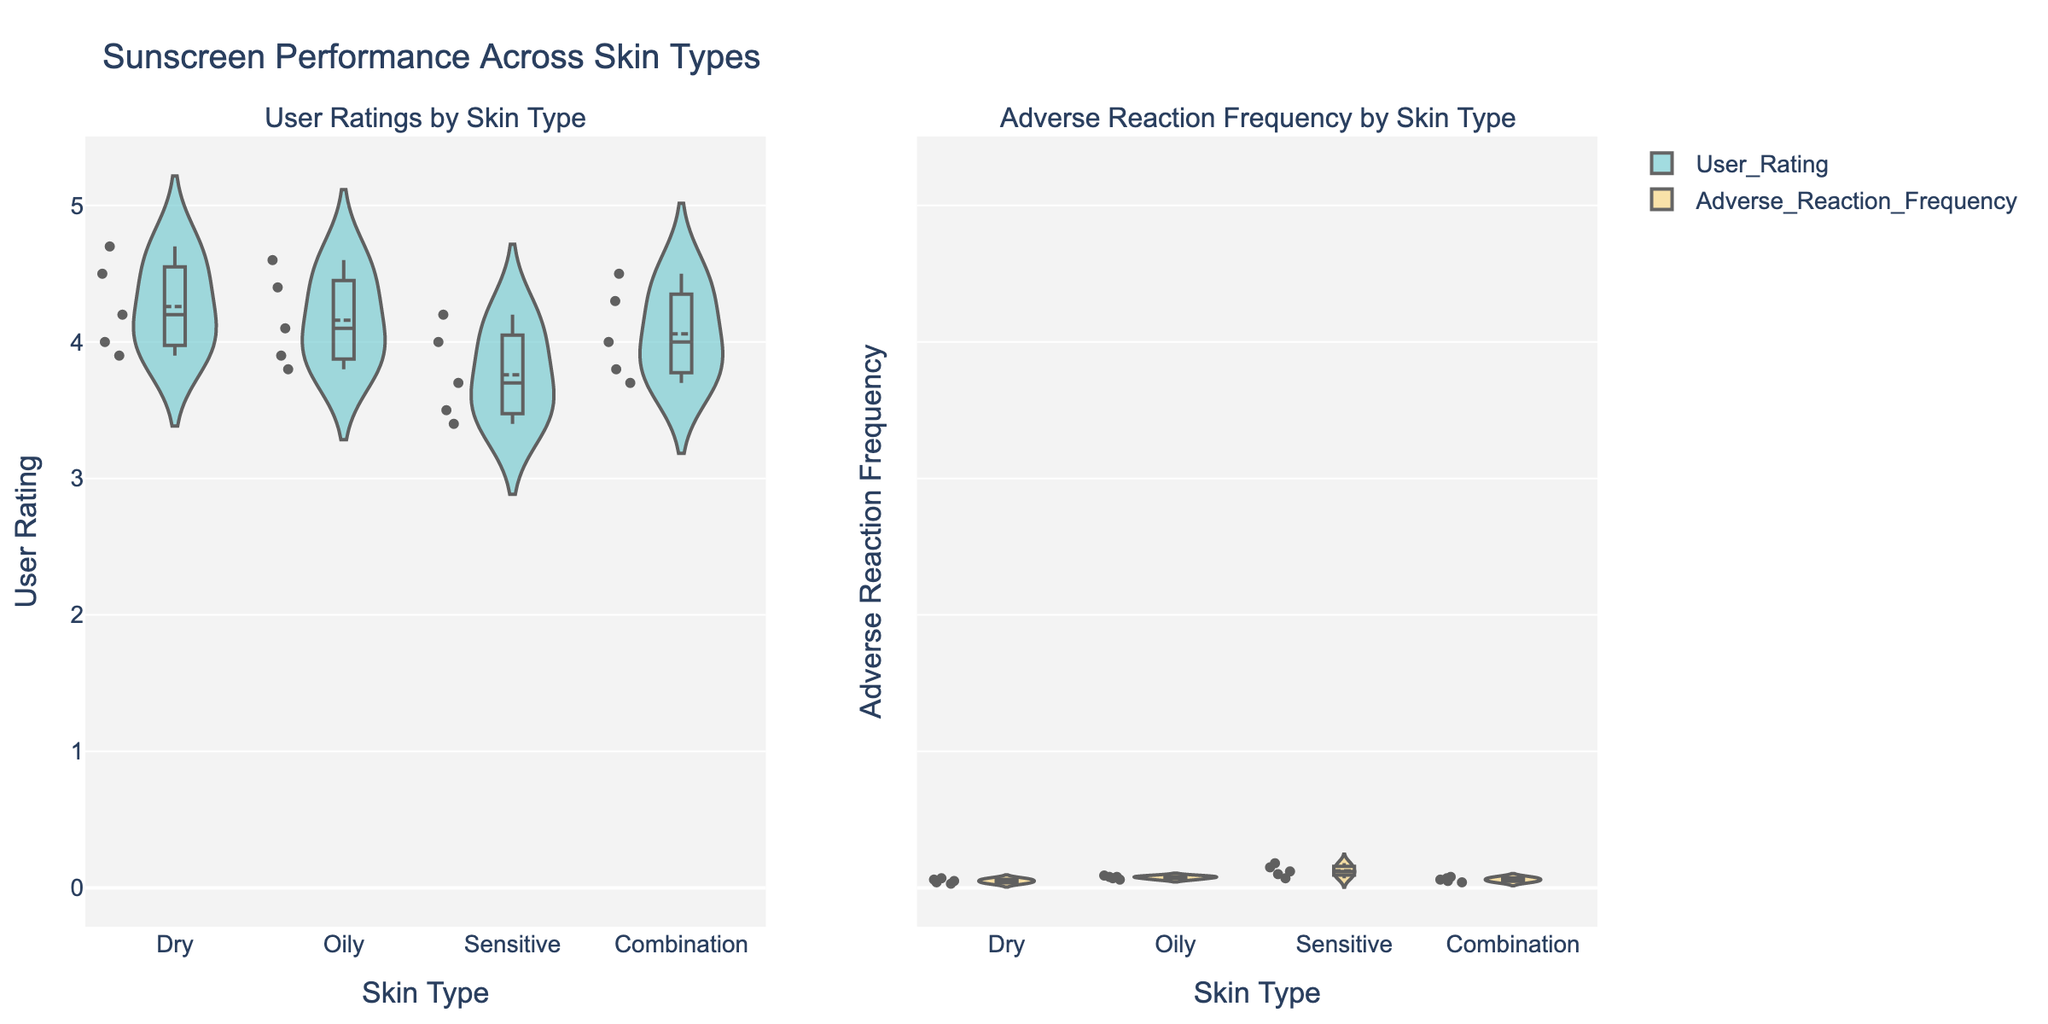What is the title of the figure? The title is located at the top center of the figure and reads "Sunscreen Performance Across Skin Types".
Answer: Sunscreen Performance Across Skin Types How many plotting areas are present in the figure? The figure is divided into two main columns, one for "User Ratings by Skin Type" and the other for "Adverse Reaction Frequency by Skin Type".
Answer: Two What is the range of user ratings for Dry skin type? The range can be determined by looking at the spread of the violin plot for Dry skin type in the User Ratings section. The minimum rating is around 3.9, and the maximum is approximately 4.7.
Answer: 3.9 to 4.7 Which sunscreen brand has the lowest user rating for Sensitive skin type? By examining the plot for Sensitive skin type in the User Ratings section, the lowest user rating is around 3.4 for Cetaphil Daily Facial Moisturizer.
Answer: Cetaphil Daily Facial Moisturizer Which skin type has the highest median user rating? Median values are indicated by a thicker line in the center of the box plot within the violin plot. Combination skin type shows the highest median in the User Ratings section.
Answer: Combination How does the adverse reaction frequency compare between Dry and Oily skin types? By comparing the violin plots in the Adverse Reaction Frequency section, Oily skin type shows higher adverse reaction frequencies, with a median around 0.08, while Dry skin type has a median closer to 0.06.
Answer: Oily > Dry Which skin type displays the greatest variability in user ratings? Variability in user ratings can be observed by the width and spread of the violin plot in the User Ratings section. Sensitive skin type shows the greatest spread, indicating high variability.
Answer: Sensitive Is the mean user rating for La Roche-Posay Anthelios higher than the mean rating for Neutrogena Ultra Sheer? By comparing the mean lines in the User Ratings section for these two products, La Roche-Posay Anthelios has a higher mean user rating compared to Neutrogena Ultra Sheer.
Answer: Yes What brand has the lowest adverse reaction frequency for Dry skin type? In the Adverse Reaction Frequency section, focus on the Dry skin type and observe the points. EltaMD UV Clear has the lowest adverse reaction frequency.
Answer: EltaMD UV Clear How do user ratings correlate with adverse reaction frequency for Sensitive skin type? Compare the violin plots for Sensitive skin type across both sections. Lower user ratings correlate with higher adverse reaction frequencies, particularly for Cetaphil Daily Facial Moisturizer.
Answer: Negatively correlated 